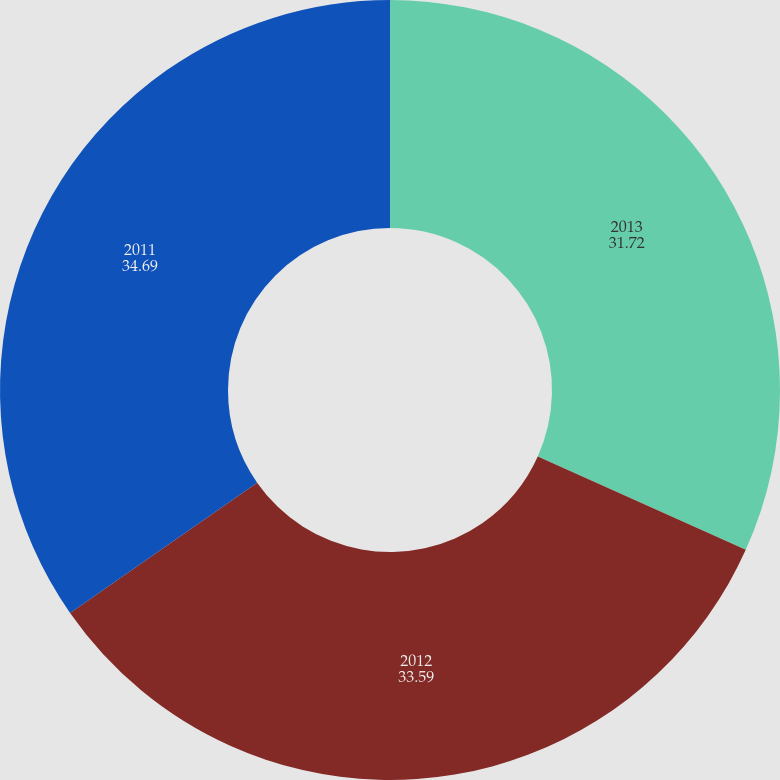<chart> <loc_0><loc_0><loc_500><loc_500><pie_chart><fcel>2013<fcel>2012<fcel>2011<nl><fcel>31.72%<fcel>33.59%<fcel>34.69%<nl></chart> 